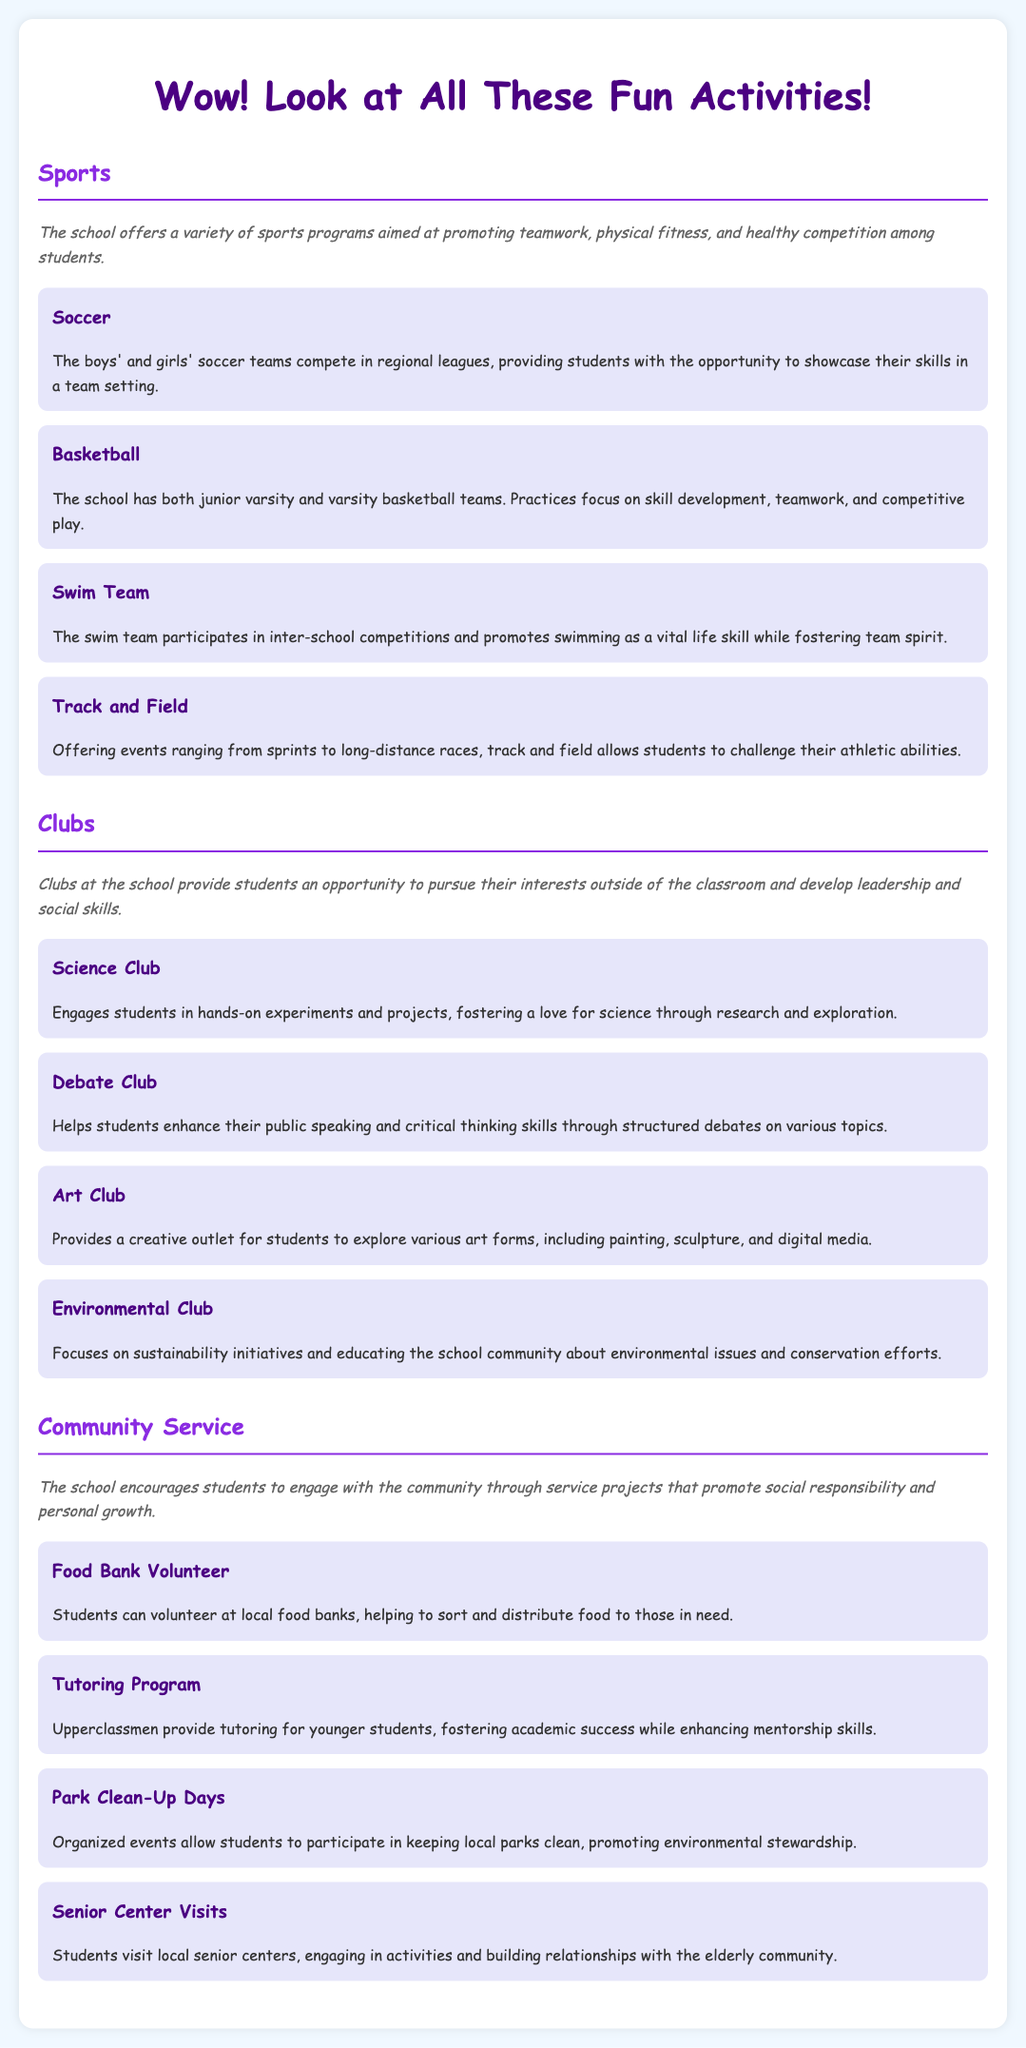what sports are offered at the school? The document lists four sports activities: Soccer, Basketball, Swim Team, and Track and Field.
Answer: Soccer, Basketball, Swim Team, Track and Field how many community service opportunities are mentioned? There are four community service activities listed: Food Bank Volunteer, Tutoring Program, Park Clean-Up Days, and Senior Center Visits.
Answer: Four what is the focus of the Environmental Club? The Environmental Club emphasizes sustainability and educating the community about environmental issues.
Answer: Sustainability initiatives which activity helps enhance public speaking skills? The Debate Club focuses on improving public speaking and critical thinking through debates.
Answer: Debate Club What kind of teams does the school have for basketball? The document specifies that the school has junior varsity and varsity basketball teams.
Answer: Junior varsity and varsity 